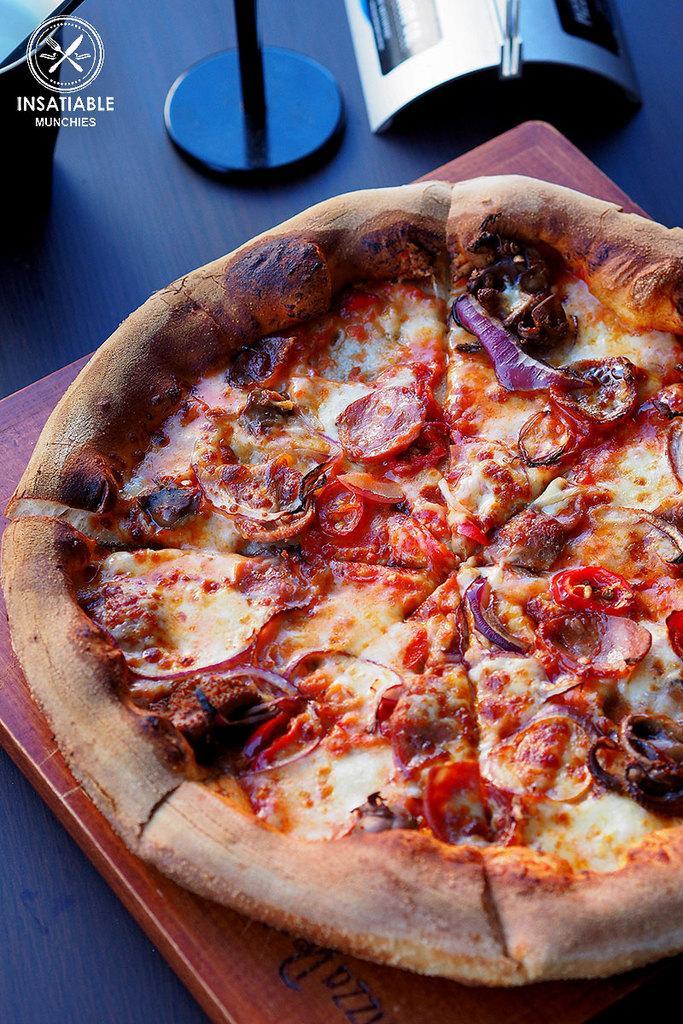In one or two sentences, can you explain what this image depicts? In the image we can see there is a picture in which there is a pizza kept on the plate and the plate is kept on the table. 